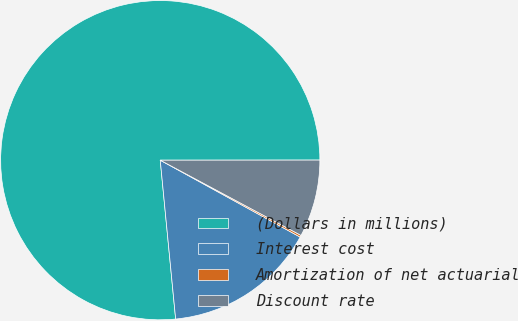<chart> <loc_0><loc_0><loc_500><loc_500><pie_chart><fcel>(Dollars in millions)<fcel>Interest cost<fcel>Amortization of net actuarial<fcel>Discount rate<nl><fcel>76.53%<fcel>15.46%<fcel>0.19%<fcel>7.82%<nl></chart> 